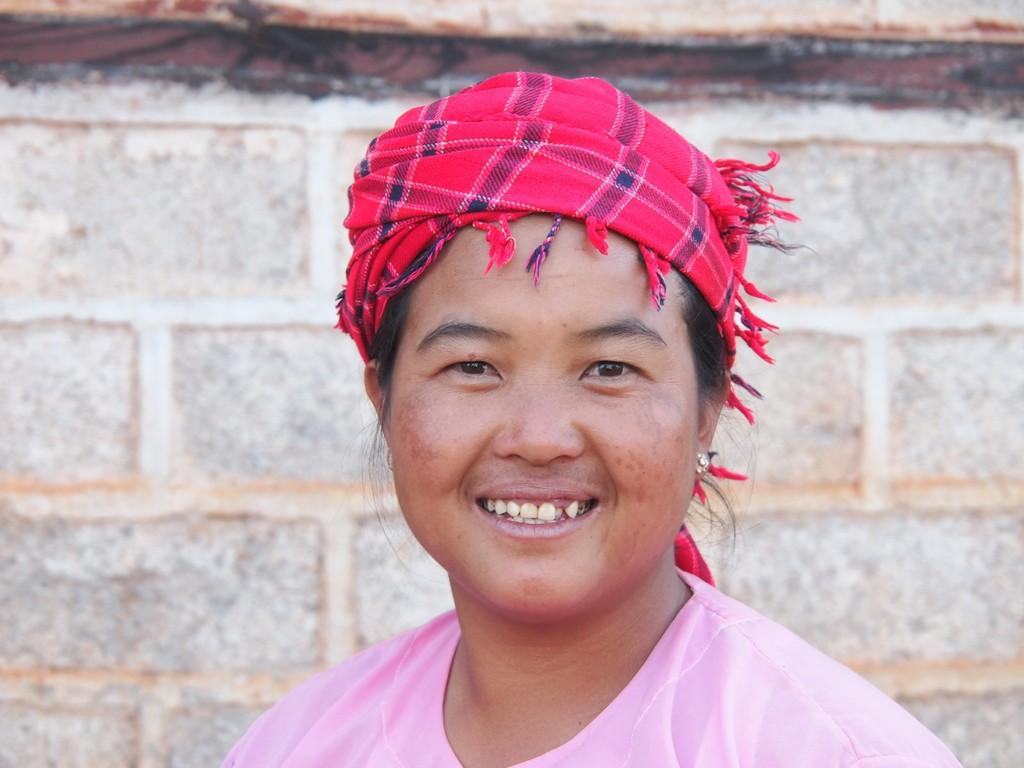What is present in the image? There is a woman in the image. What can be seen in the background of the image? There is a wall in the background of the image. What type of bubble can be seen floating near the woman in the image? There is no bubble present in the image. What activity is the woman engaged in with the play equipment in the image? There is no play equipment present in the image. 